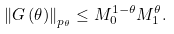Convert formula to latex. <formula><loc_0><loc_0><loc_500><loc_500>\left \| G \left ( \theta \right ) \right \| _ { p _ { \theta } } \leq M _ { 0 } ^ { 1 - \theta } M _ { 1 } ^ { \theta } .</formula> 